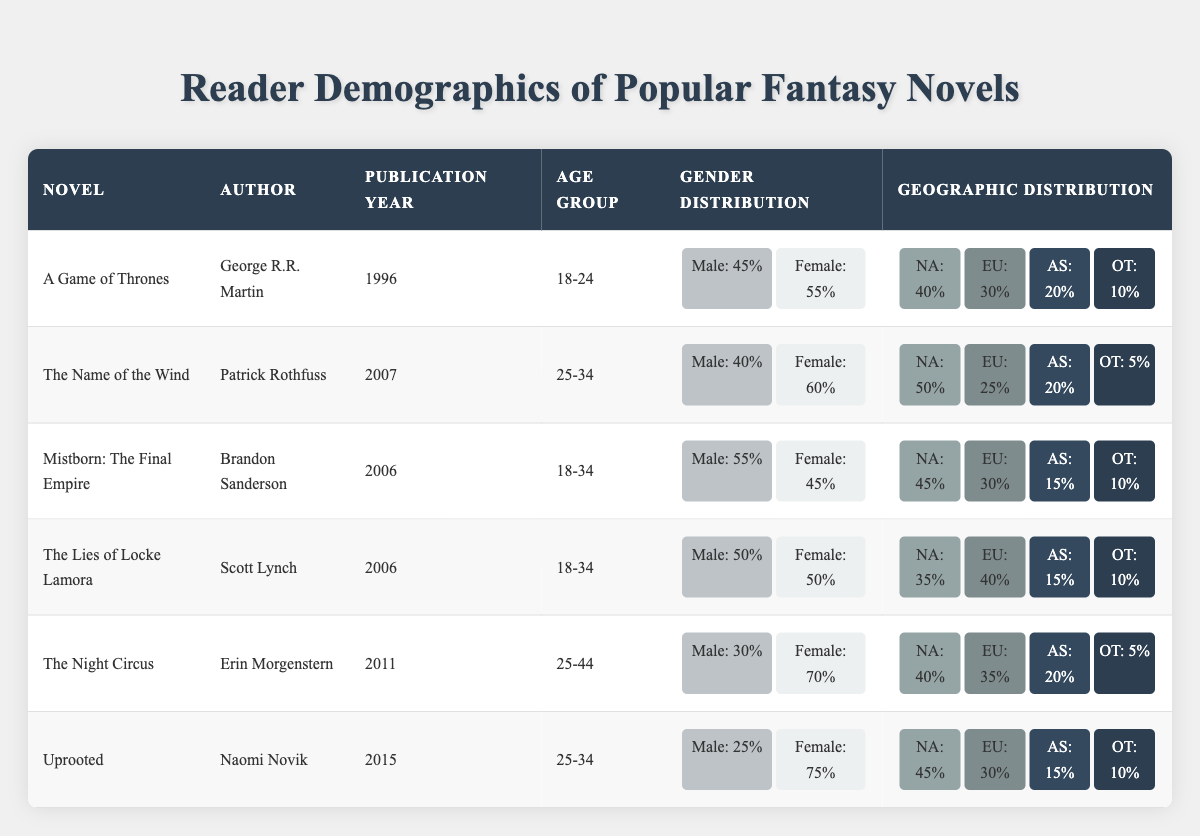What is the publication year of "The Night Circus"? The publication year is listed in the table, and for "The Night Circus," it shows 2011.
Answer: 2011 Which fantasy novel has the highest percentage of female readers in the age group 25-34? By looking at the "Gender Distribution" section for the novels in the 25-34 age group, "Uprooted" has the highest female percentage at 75%.
Answer: Uprooted How many novels were published between 2006 and 2011? The novels published in that time frame are "Mistborn: The Final Empire" (2006), "The Lies of Locke Lamora" (2006), "The Night Circus" (2011), and "Uprooted" (2015). Counting the relevant years reveals 4 novels were published within that range.
Answer: 4 Which novel has the highest percentage of male readers among the age group 18-34? Both "Mistborn: The Final Empire" and "The Lies of Locke Lamora" fall within that age group, showing 55% and 50% male readers, respectively. "Mistborn: The Final Empire" has the highest at 55%.
Answer: Mistborn: The Final Empire What is the total percentage of readers from Europe for all the novels listed? The European percentages from the table are 30% for "A Game of Thrones," 25% for "The Name of the Wind," 30% for "Mistborn: The Final Empire," 40% for "The Lies of Locke Lamora," 35% for "The Night Circus," and 30% for "Uprooted." Adding them gives 30 + 25 + 30 + 40 + 35 + 30 = 220%.
Answer: 220% Is "The Name of the Wind" more popular in North America or Europe? "The Name of the Wind" shows 50% in North America and 25% in Europe. Since 50% is greater than 25%, it is more popular in North America.
Answer: Yes Which novel shows a gender distribution of exactly 50% male and 50% female? By analyzing the gender distributions in the table, "The Lies of Locke Lamora" shows a distribution of 50% male and 50% female readers.
Answer: The Lies of Locke Lamora What is the average percentage of Asian readers across all the novels? The Asian percentages are 20% ("A Game of Thrones"), 20% ("The Name of the Wind"), 15% ("Mistborn: The Final Empire"), 15% ("The Lies of Locke Lamora"), 20% ("The Night Circus"), and 15% ("Uprooted"). Adding them gives 20 + 20 + 15 + 15 + 20 + 15 = 105%, and dividing by 6 gives an average of 17.5%.
Answer: 17.5% Which author has the highest percentage of female readers overall? The authors and their female percentages are: George R.R. Martin (55%), Patrick Rothfuss (60%), Brandon Sanderson (45%), Scott Lynch (50%), Erin Morgenstern (70%), and Naomi Novik (75%). Naomi Novik has the highest at 75%.
Answer: Naomi Novik 